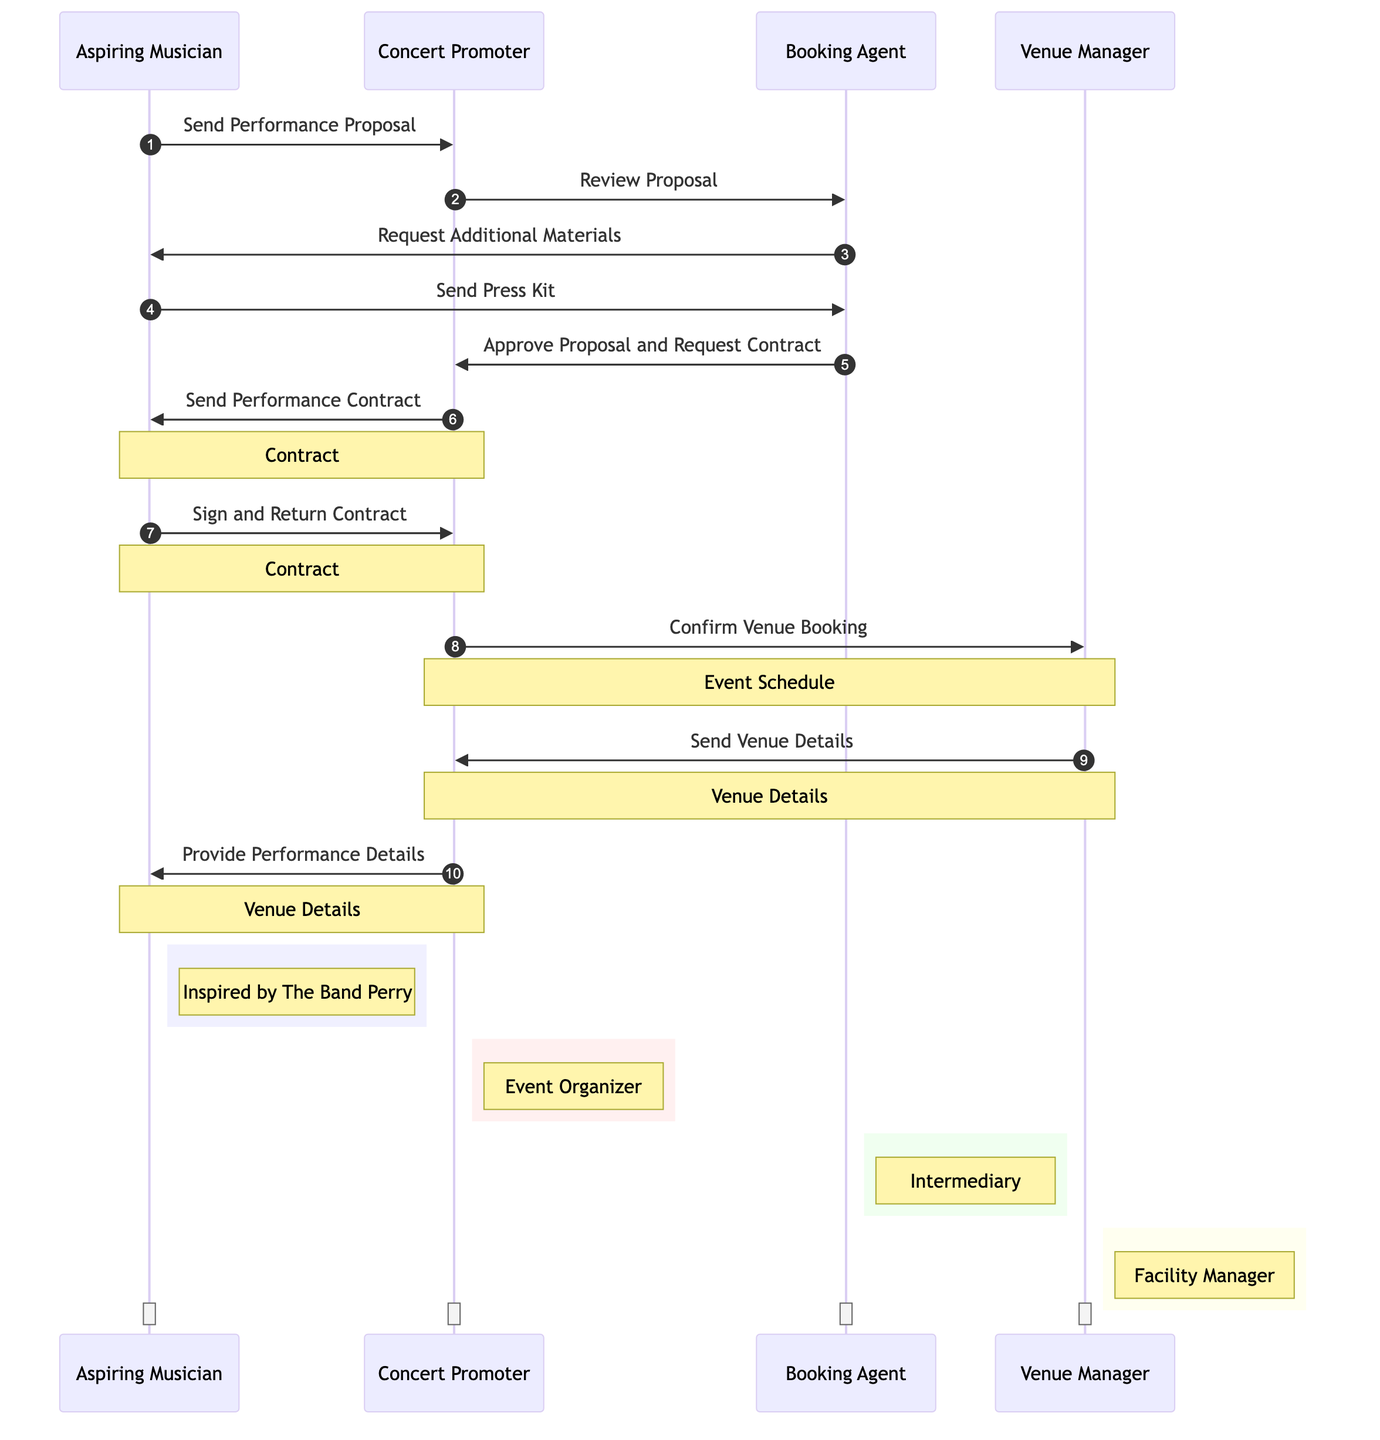What is the first action taken by the Aspiring Musician? The diagram shows the sequence of actions starting with the Aspiring Musician sending the performance proposal to the Concert Promoter. This is the first step represented in the diagram.
Answer: Send Performance Proposal Who does the Concert Promoter consult after receiving the proposal? After the Concert Promoter receives the proposal, they consult the Booking Agent to review the proposal. This is the immediate next action shown in the diagram.
Answer: Booking Agent How many main participants are involved in this process? The diagram lists four main participants: Aspiring Musician, Concert Promoter, Booking Agent, and Venue Manager, making a total of four participants.
Answer: Four What document is sent after the Aspiring Musician signs the contract? Following the signing and returning of the contract by the Aspiring Musician, there are no documents specifically shown being sent afterward in the diagram. The next step involves confirming venue booking, not sending another document.
Answer: None Which participant provides details about the venue? The Venue Manager sends the venue details to the Concert Promoter, who subsequently provides performance details to the Aspiring Musician, as represented in the sequence.
Answer: Venue Manager What is the last step before the Aspiring Musician receives performance details? The last step before the Aspiring Musician receives performance details is that the Venue Manager sends the venue details to the Concert Promoter, who has to act based on this information.
Answer: Send Venue Details Which participant requests additional materials? The Booking Agent requests additional materials from the Aspiring Musician, indicating that further information is needed to move forward with the booking process.
Answer: Booking Agent How many direct messages does the Concert Promoter send? The Concert Promoter sends three direct messages throughout the sequence: one to the Booking Agent for reviewing the proposal, one to the Aspiring Musician for sending the performance contract, and one to provide performance details after confirming the venue.
Answer: Three What is the status of the contract during the interaction between the Aspiring Musician and the Concert Promoter? During their interaction, the contract is noted with the statement "Contract", indicating that it's an important document in their exchange, marked in the diagram as significant.
Answer: Contract 